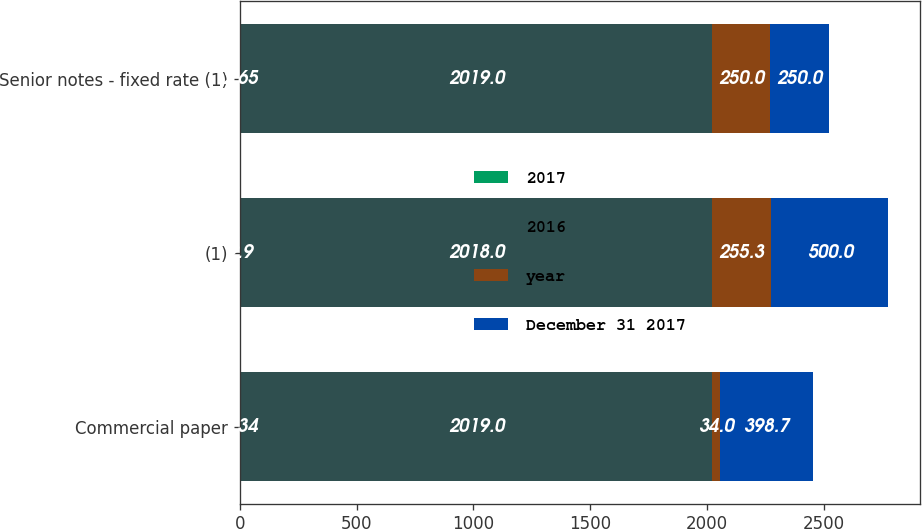Convert chart to OTSL. <chart><loc_0><loc_0><loc_500><loc_500><stacked_bar_chart><ecel><fcel>Commercial paper<fcel>(1)<fcel>Senior notes - fixed rate (1)<nl><fcel>2017<fcel>2.34<fcel>2.9<fcel>2.65<nl><fcel>2016<fcel>2019<fcel>2018<fcel>2019<nl><fcel>year<fcel>34<fcel>255.3<fcel>250<nl><fcel>December 31 2017<fcel>398.7<fcel>500<fcel>250<nl></chart> 